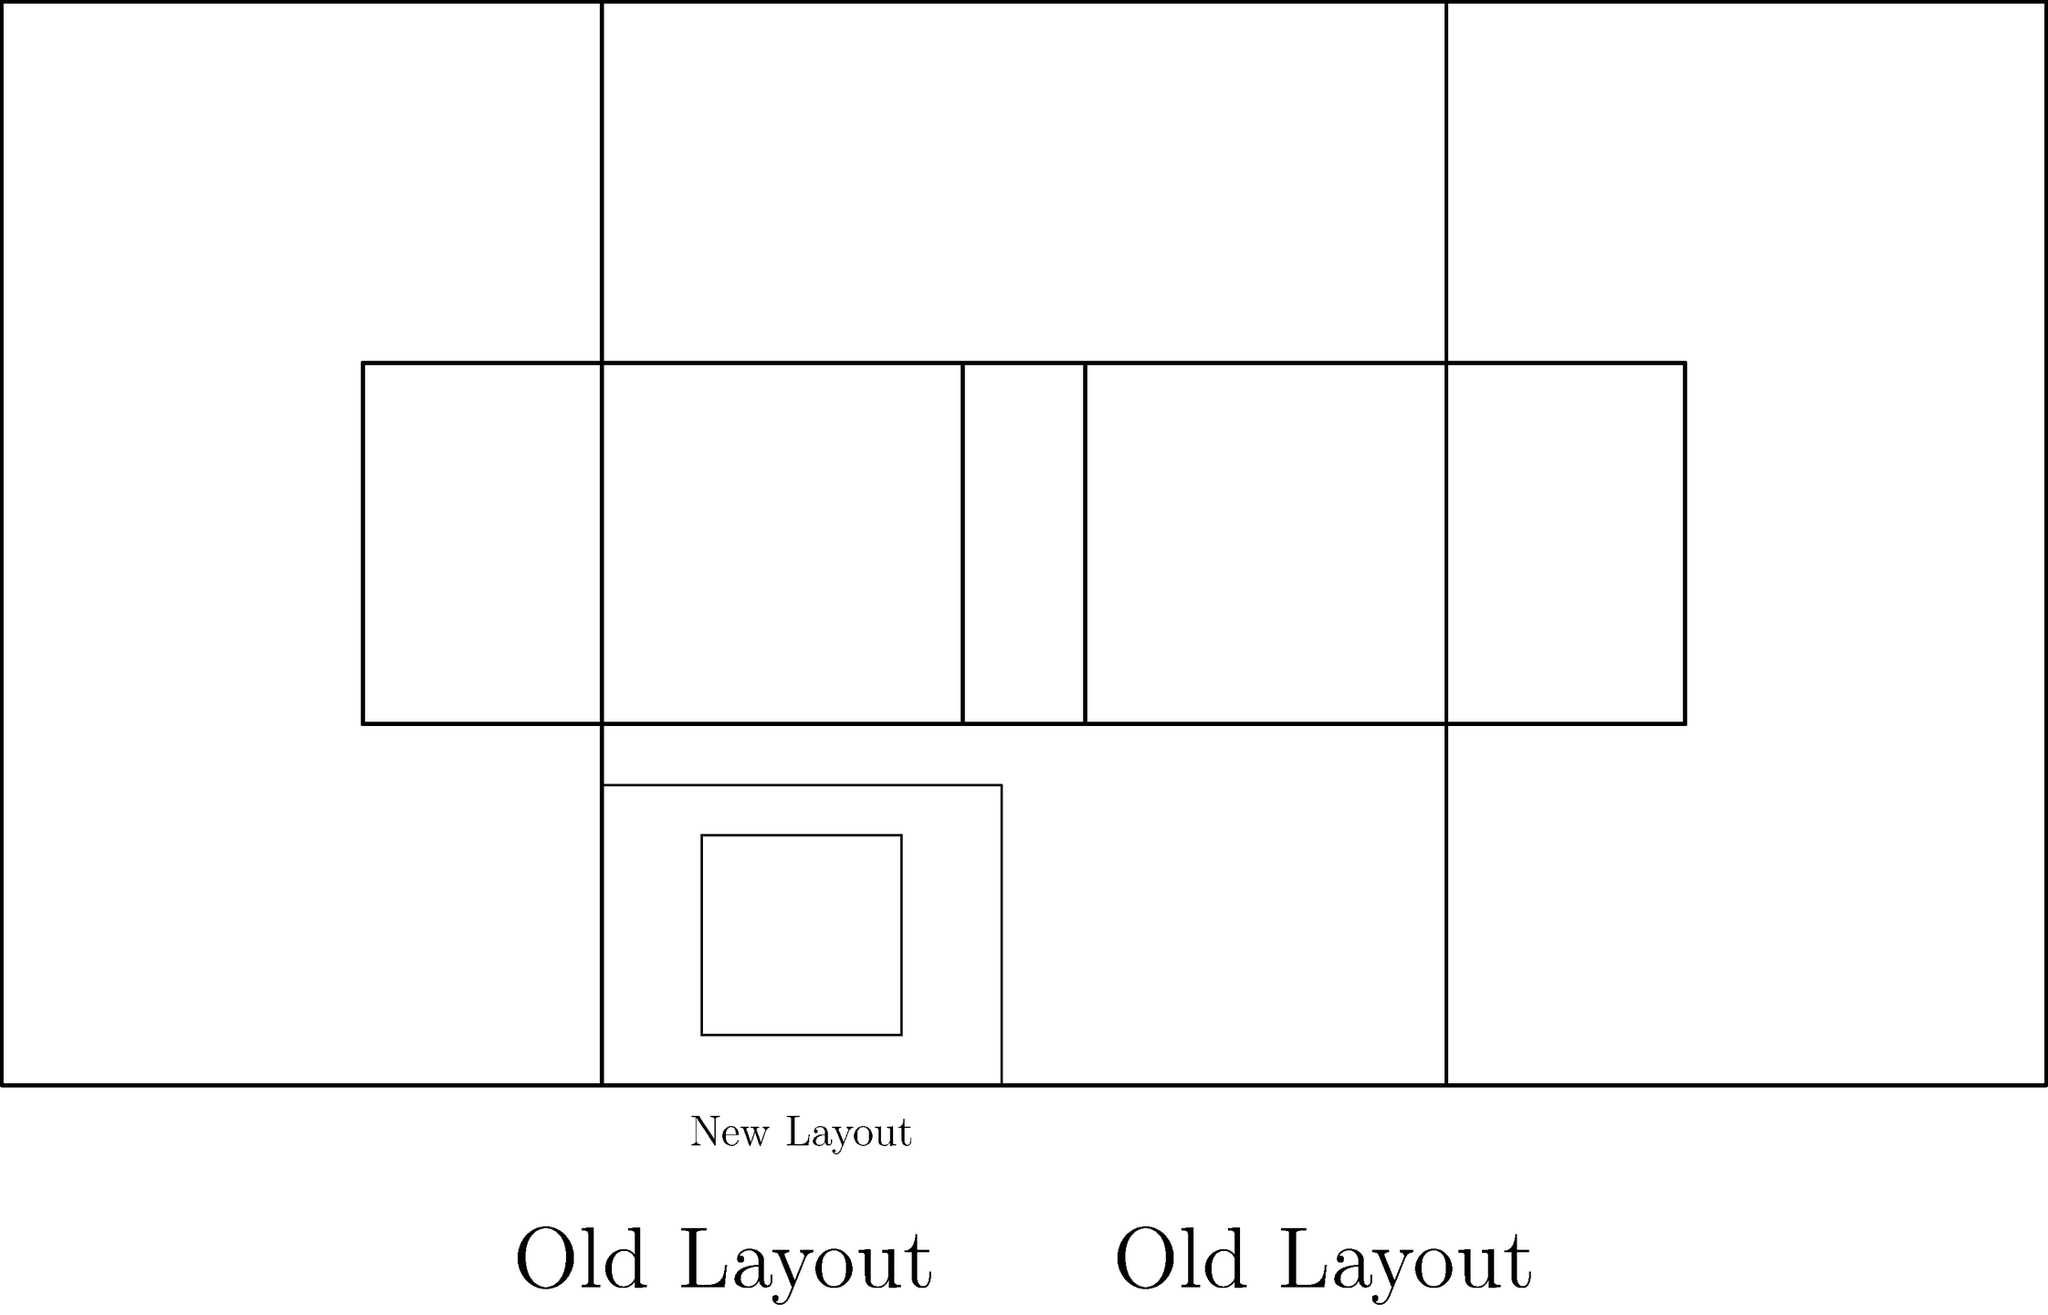As a long-time resident, you notice that the city has redesigned the neighborhood park. The old and new layouts are shown above. Are the inner rectangles (representing the playground area) in both layouts congruent to each other? To determine if the inner rectangles are congruent, we need to compare their dimensions:

1. Old Layout:
   Width = 3 - 1 = 2 units
   Height = 2 - 1 = 1 unit

2. New Layout:
   Width = 9 - 7 = 2 units
   Height = 2.5 - 0.5 = 2 units

3. For rectangles to be congruent, they must have the same dimensions.

4. Comparing the dimensions:
   - The widths are the same (2 units)
   - The heights are different (1 unit vs 2 units)

5. Since the heights are different, the rectangles are not congruent.
Answer: No 